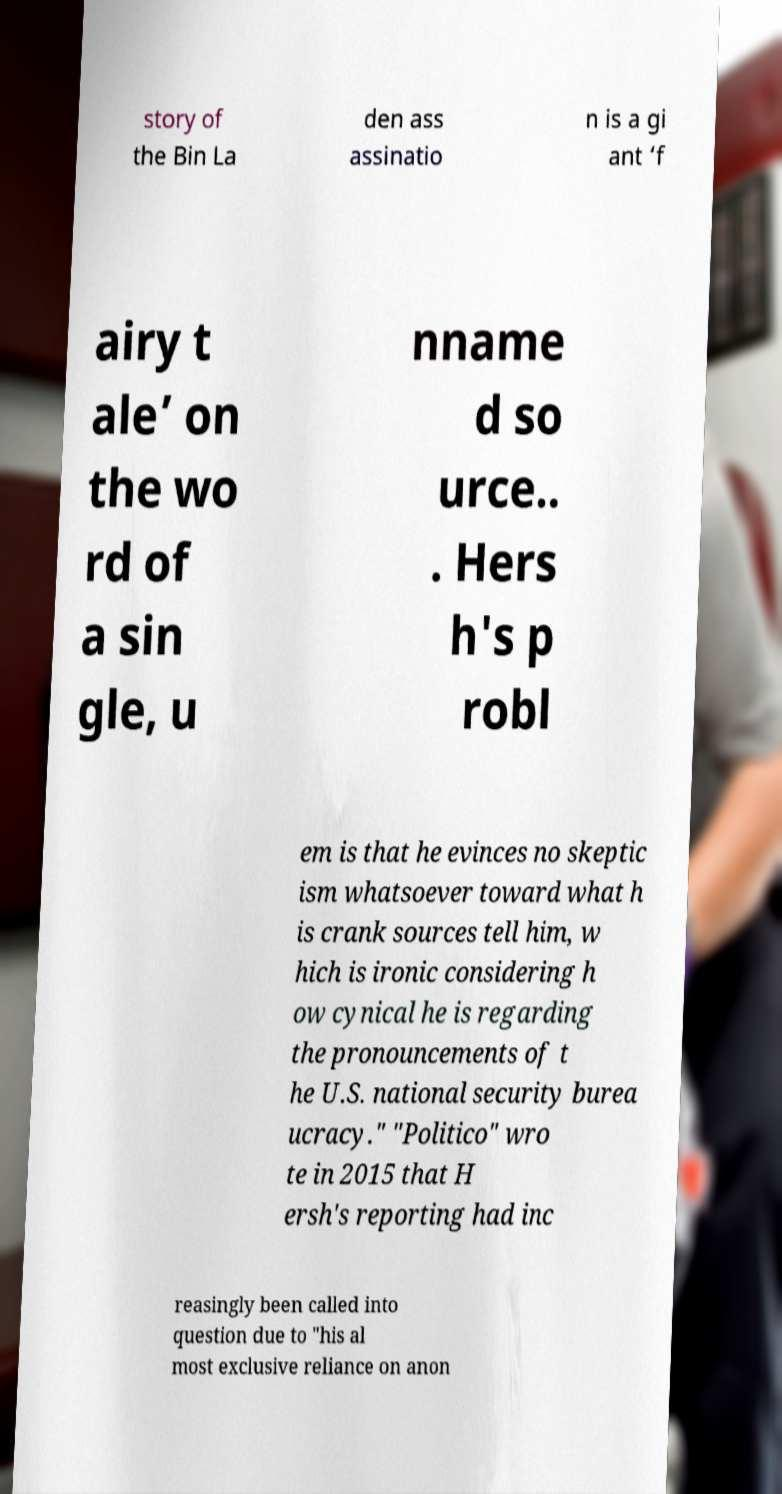Can you read and provide the text displayed in the image?This photo seems to have some interesting text. Can you extract and type it out for me? story of the Bin La den ass assinatio n is a gi ant ‘f airy t ale’ on the wo rd of a sin gle, u nname d so urce.. . Hers h's p robl em is that he evinces no skeptic ism whatsoever toward what h is crank sources tell him, w hich is ironic considering h ow cynical he is regarding the pronouncements of t he U.S. national security burea ucracy." "Politico" wro te in 2015 that H ersh's reporting had inc reasingly been called into question due to "his al most exclusive reliance on anon 